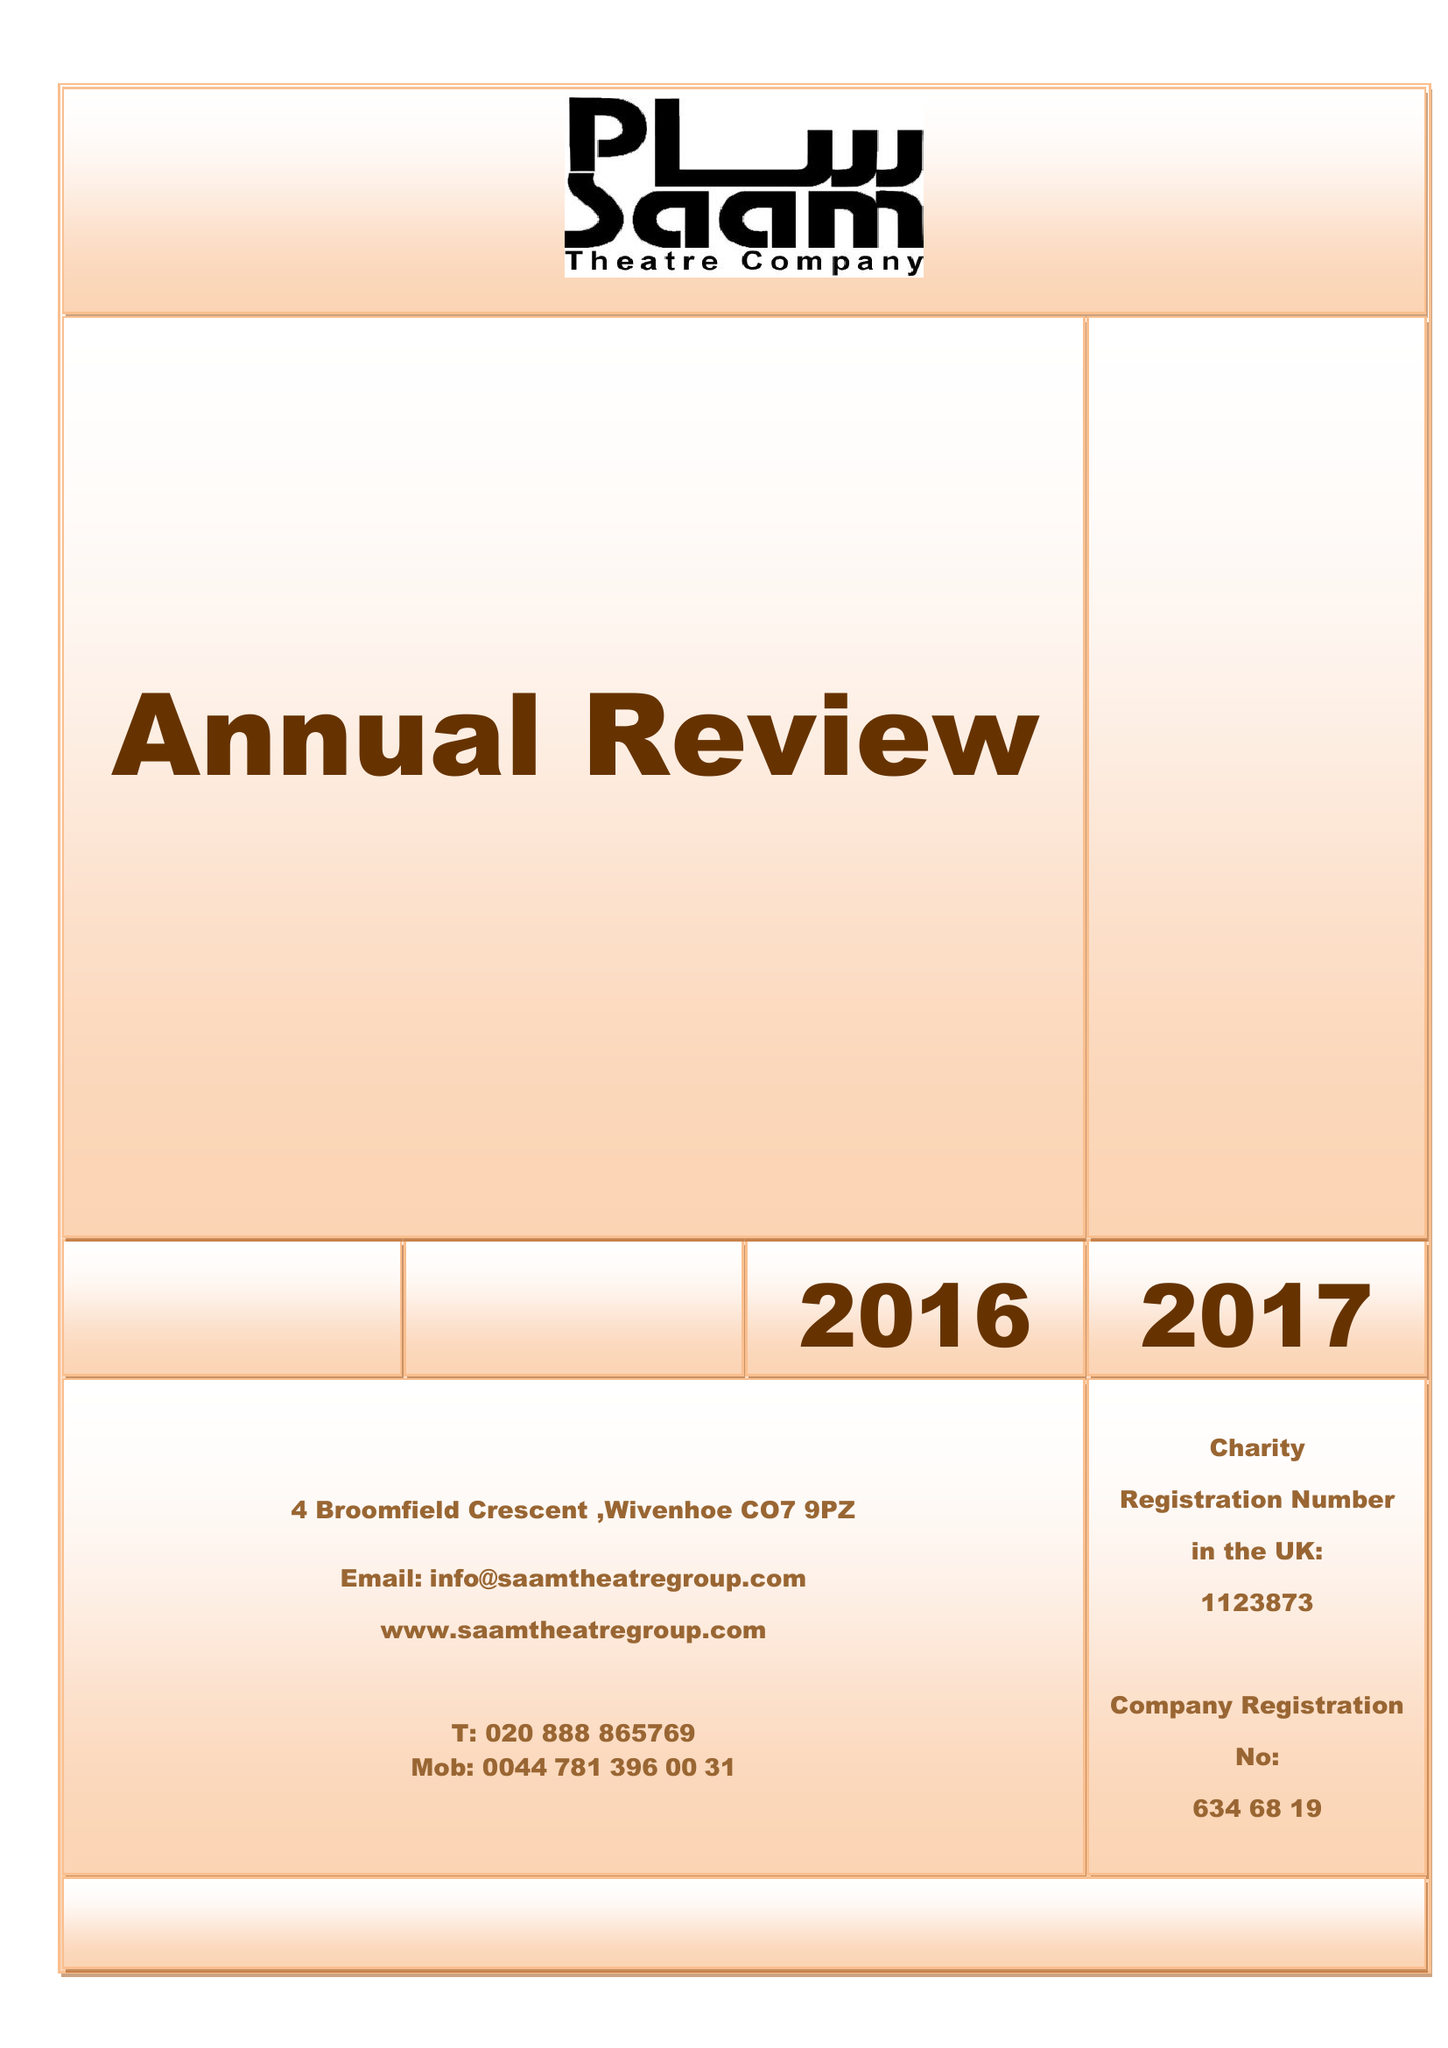What is the value for the charity_number?
Answer the question using a single word or phrase. 1123873 